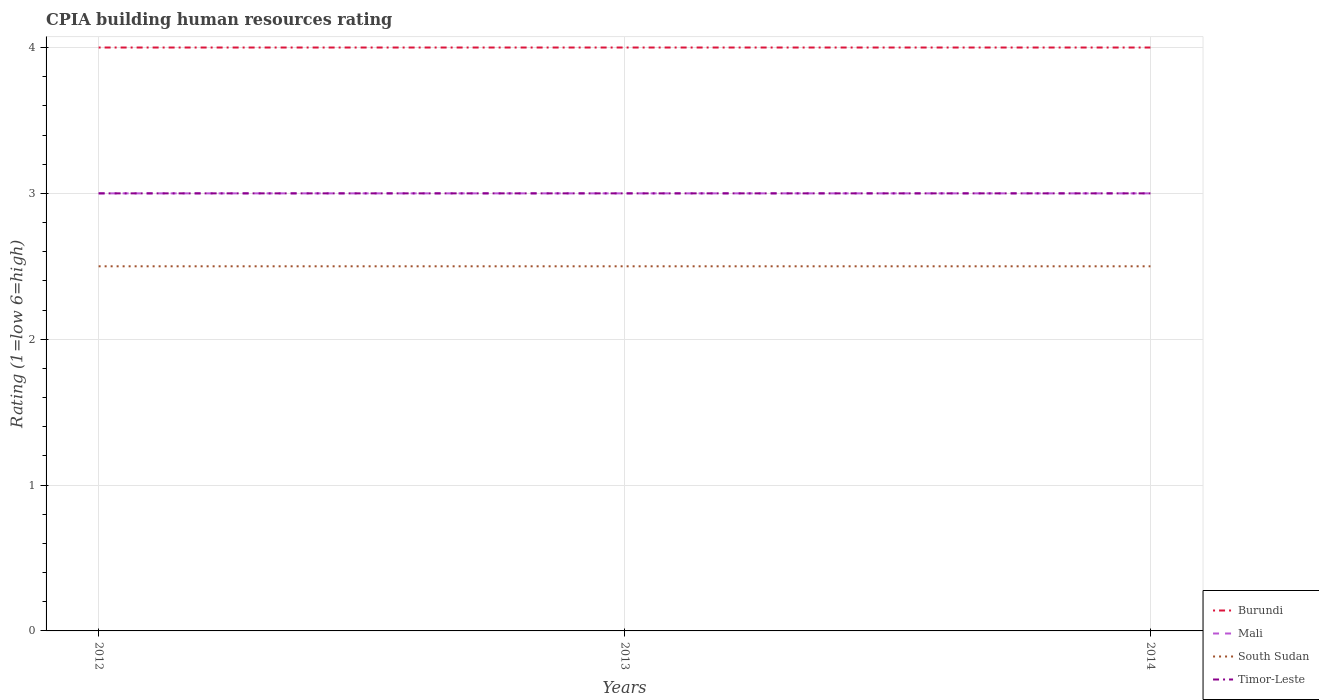What is the total CPIA rating in Timor-Leste in the graph?
Offer a very short reply. 0. Is the CPIA rating in Burundi strictly greater than the CPIA rating in South Sudan over the years?
Offer a very short reply. No. How many years are there in the graph?
Provide a short and direct response. 3. Where does the legend appear in the graph?
Keep it short and to the point. Bottom right. How many legend labels are there?
Offer a terse response. 4. How are the legend labels stacked?
Ensure brevity in your answer.  Vertical. What is the title of the graph?
Provide a short and direct response. CPIA building human resources rating. Does "Czech Republic" appear as one of the legend labels in the graph?
Offer a terse response. No. What is the label or title of the X-axis?
Keep it short and to the point. Years. What is the Rating (1=low 6=high) of Mali in 2012?
Your response must be concise. 3. What is the Rating (1=low 6=high) in South Sudan in 2012?
Your response must be concise. 2.5. What is the Rating (1=low 6=high) of Timor-Leste in 2012?
Your answer should be very brief. 3. What is the Rating (1=low 6=high) of Burundi in 2013?
Make the answer very short. 4. What is the Rating (1=low 6=high) of Mali in 2013?
Provide a short and direct response. 3. What is the Rating (1=low 6=high) in Timor-Leste in 2013?
Make the answer very short. 3. What is the Rating (1=low 6=high) of Burundi in 2014?
Provide a short and direct response. 4. Across all years, what is the maximum Rating (1=low 6=high) in Mali?
Offer a very short reply. 3. Across all years, what is the maximum Rating (1=low 6=high) in Timor-Leste?
Your response must be concise. 3. Across all years, what is the minimum Rating (1=low 6=high) in Mali?
Provide a succinct answer. 3. What is the total Rating (1=low 6=high) of Timor-Leste in the graph?
Your answer should be compact. 9. What is the difference between the Rating (1=low 6=high) in Mali in 2012 and that in 2013?
Offer a very short reply. 0. What is the difference between the Rating (1=low 6=high) of South Sudan in 2012 and that in 2013?
Provide a succinct answer. 0. What is the difference between the Rating (1=low 6=high) in Burundi in 2012 and that in 2014?
Offer a very short reply. 0. What is the difference between the Rating (1=low 6=high) in Mali in 2012 and that in 2014?
Ensure brevity in your answer.  0. What is the difference between the Rating (1=low 6=high) in South Sudan in 2012 and that in 2014?
Provide a short and direct response. 0. What is the difference between the Rating (1=low 6=high) in Timor-Leste in 2012 and that in 2014?
Keep it short and to the point. 0. What is the difference between the Rating (1=low 6=high) in South Sudan in 2013 and that in 2014?
Your answer should be compact. 0. What is the difference between the Rating (1=low 6=high) of Timor-Leste in 2013 and that in 2014?
Make the answer very short. 0. What is the difference between the Rating (1=low 6=high) of Burundi in 2012 and the Rating (1=low 6=high) of Mali in 2013?
Ensure brevity in your answer.  1. What is the difference between the Rating (1=low 6=high) of Burundi in 2012 and the Rating (1=low 6=high) of South Sudan in 2013?
Offer a terse response. 1.5. What is the difference between the Rating (1=low 6=high) of Burundi in 2012 and the Rating (1=low 6=high) of South Sudan in 2014?
Offer a very short reply. 1.5. What is the difference between the Rating (1=low 6=high) of Burundi in 2012 and the Rating (1=low 6=high) of Timor-Leste in 2014?
Offer a very short reply. 1. What is the difference between the Rating (1=low 6=high) in South Sudan in 2012 and the Rating (1=low 6=high) in Timor-Leste in 2014?
Offer a terse response. -0.5. What is the difference between the Rating (1=low 6=high) in Burundi in 2013 and the Rating (1=low 6=high) in South Sudan in 2014?
Your response must be concise. 1.5. What is the difference between the Rating (1=low 6=high) in Burundi in 2013 and the Rating (1=low 6=high) in Timor-Leste in 2014?
Your response must be concise. 1. What is the difference between the Rating (1=low 6=high) of Mali in 2013 and the Rating (1=low 6=high) of South Sudan in 2014?
Make the answer very short. 0.5. What is the difference between the Rating (1=low 6=high) in Mali in 2013 and the Rating (1=low 6=high) in Timor-Leste in 2014?
Your response must be concise. 0. What is the average Rating (1=low 6=high) of South Sudan per year?
Provide a succinct answer. 2.5. What is the average Rating (1=low 6=high) of Timor-Leste per year?
Make the answer very short. 3. In the year 2012, what is the difference between the Rating (1=low 6=high) in Burundi and Rating (1=low 6=high) in South Sudan?
Keep it short and to the point. 1.5. In the year 2012, what is the difference between the Rating (1=low 6=high) in Burundi and Rating (1=low 6=high) in Timor-Leste?
Ensure brevity in your answer.  1. In the year 2012, what is the difference between the Rating (1=low 6=high) in Mali and Rating (1=low 6=high) in South Sudan?
Offer a terse response. 0.5. In the year 2012, what is the difference between the Rating (1=low 6=high) in Mali and Rating (1=low 6=high) in Timor-Leste?
Your answer should be compact. 0. In the year 2012, what is the difference between the Rating (1=low 6=high) of South Sudan and Rating (1=low 6=high) of Timor-Leste?
Keep it short and to the point. -0.5. In the year 2013, what is the difference between the Rating (1=low 6=high) in Burundi and Rating (1=low 6=high) in South Sudan?
Keep it short and to the point. 1.5. In the year 2013, what is the difference between the Rating (1=low 6=high) in South Sudan and Rating (1=low 6=high) in Timor-Leste?
Make the answer very short. -0.5. In the year 2014, what is the difference between the Rating (1=low 6=high) of Burundi and Rating (1=low 6=high) of Timor-Leste?
Keep it short and to the point. 1. In the year 2014, what is the difference between the Rating (1=low 6=high) in Mali and Rating (1=low 6=high) in Timor-Leste?
Give a very brief answer. 0. What is the ratio of the Rating (1=low 6=high) of Mali in 2012 to that in 2013?
Give a very brief answer. 1. What is the ratio of the Rating (1=low 6=high) in Burundi in 2012 to that in 2014?
Your response must be concise. 1. What is the ratio of the Rating (1=low 6=high) of Burundi in 2013 to that in 2014?
Offer a very short reply. 1. What is the ratio of the Rating (1=low 6=high) of Mali in 2013 to that in 2014?
Make the answer very short. 1. What is the ratio of the Rating (1=low 6=high) in South Sudan in 2013 to that in 2014?
Give a very brief answer. 1. 